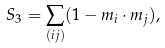<formula> <loc_0><loc_0><loc_500><loc_500>S _ { 3 } = \sum _ { ( i j ) } ( 1 - { m } _ { i } \cdot { m } _ { j } ) ,</formula> 